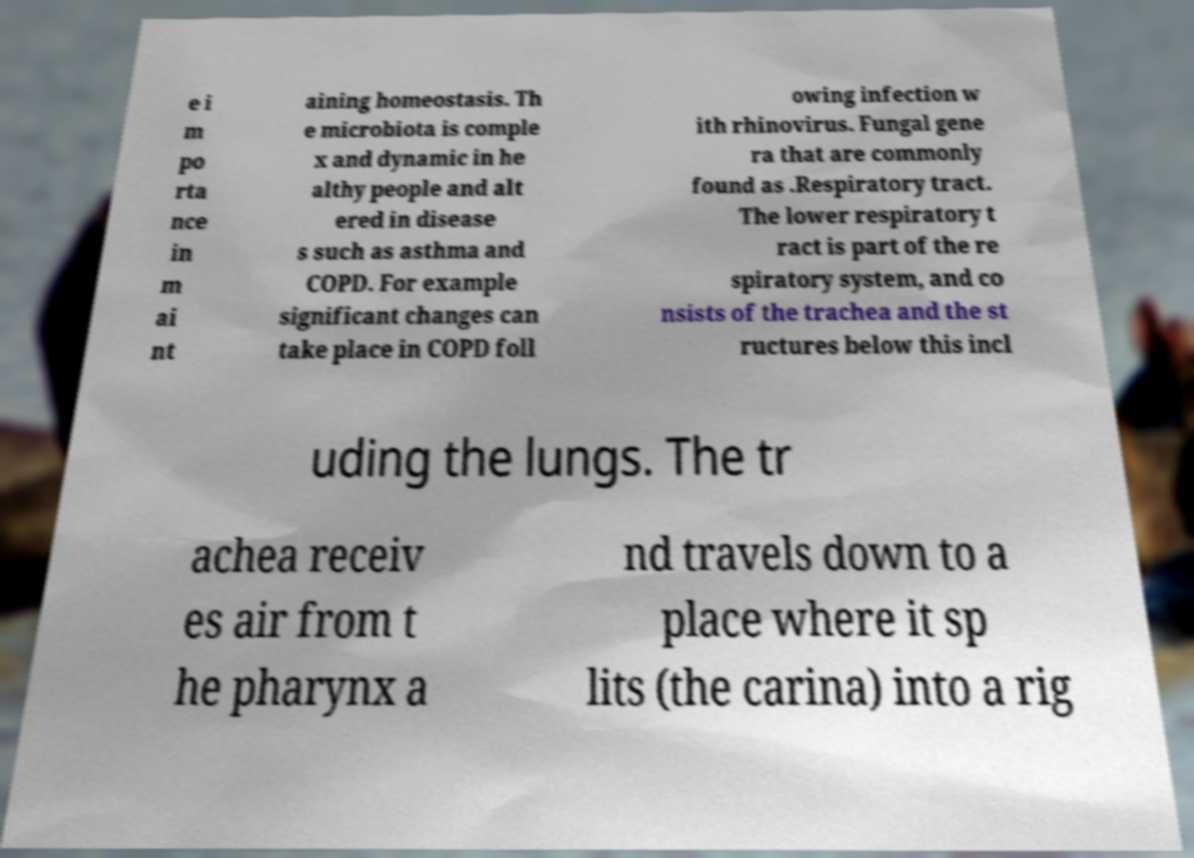Could you extract and type out the text from this image? e i m po rta nce in m ai nt aining homeostasis. Th e microbiota is comple x and dynamic in he althy people and alt ered in disease s such as asthma and COPD. For example significant changes can take place in COPD foll owing infection w ith rhinovirus. Fungal gene ra that are commonly found as .Respiratory tract. The lower respiratory t ract is part of the re spiratory system, and co nsists of the trachea and the st ructures below this incl uding the lungs. The tr achea receiv es air from t he pharynx a nd travels down to a place where it sp lits (the carina) into a rig 